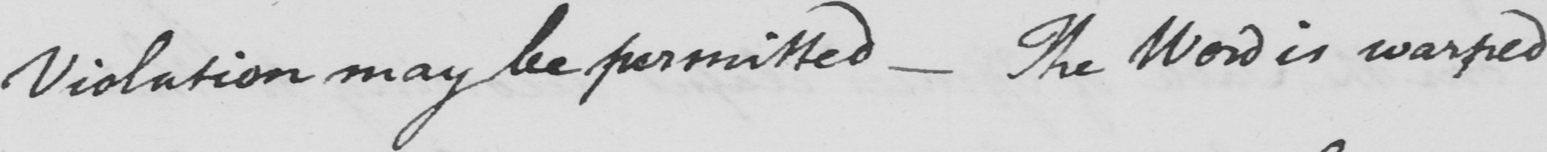What text is written in this handwritten line? Violation may be permitted _  The Word is warped 